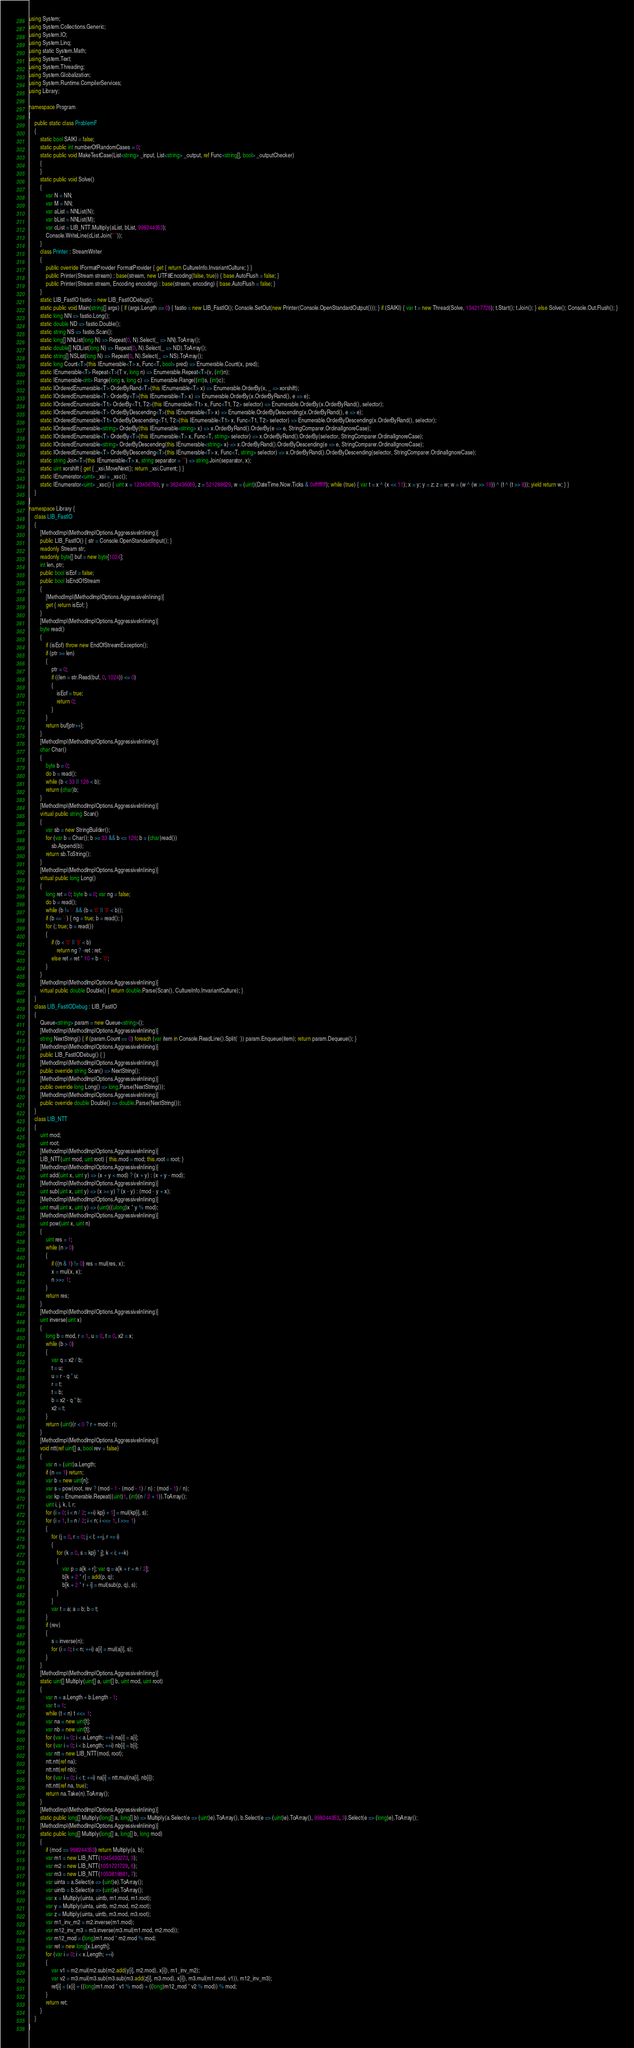<code> <loc_0><loc_0><loc_500><loc_500><_C#_>using System;
using System.Collections.Generic;
using System.IO;
using System.Linq;
using static System.Math;
using System.Text;
using System.Threading;
using System.Globalization;
using System.Runtime.CompilerServices;
using Library;

namespace Program
{
    public static class ProblemF
    {
        static bool SAIKI = false;
        static public int numberOfRandomCases = 0;
        static public void MakeTestCase(List<string> _input, List<string> _output, ref Func<string[], bool> _outputChecker)
        {
        }
        static public void Solve()
        {
            var N = NN;
            var M = NN;
            var aList = NNList(N);
            var bList = NNList(M);
            var cList = LIB_NTT.Multiply(aList, bList, 998244353);
            Console.WriteLine(cList.Join(" "));
        }
        class Printer : StreamWriter
        {
            public override IFormatProvider FormatProvider { get { return CultureInfo.InvariantCulture; } }
            public Printer(Stream stream) : base(stream, new UTF8Encoding(false, true)) { base.AutoFlush = false; }
            public Printer(Stream stream, Encoding encoding) : base(stream, encoding) { base.AutoFlush = false; }
        }
        static LIB_FastIO fastio = new LIB_FastIODebug();
        static public void Main(string[] args) { if (args.Length == 0) { fastio = new LIB_FastIO(); Console.SetOut(new Printer(Console.OpenStandardOutput())); } if (SAIKI) { var t = new Thread(Solve, 134217728); t.Start(); t.Join(); } else Solve(); Console.Out.Flush(); }
        static long NN => fastio.Long();
        static double ND => fastio.Double();
        static string NS => fastio.Scan();
        static long[] NNList(long N) => Repeat(0, N).Select(_ => NN).ToArray();
        static double[] NDList(long N) => Repeat(0, N).Select(_ => ND).ToArray();
        static string[] NSList(long N) => Repeat(0, N).Select(_ => NS).ToArray();
        static long Count<T>(this IEnumerable<T> x, Func<T, bool> pred) => Enumerable.Count(x, pred);
        static IEnumerable<T> Repeat<T>(T v, long n) => Enumerable.Repeat<T>(v, (int)n);
        static IEnumerable<int> Range(long s, long c) => Enumerable.Range((int)s, (int)c);
        static IOrderedEnumerable<T> OrderByRand<T>(this IEnumerable<T> x) => Enumerable.OrderBy(x, _ => xorshift);
        static IOrderedEnumerable<T> OrderBy<T>(this IEnumerable<T> x) => Enumerable.OrderBy(x.OrderByRand(), e => e);
        static IOrderedEnumerable<T1> OrderBy<T1, T2>(this IEnumerable<T1> x, Func<T1, T2> selector) => Enumerable.OrderBy(x.OrderByRand(), selector);
        static IOrderedEnumerable<T> OrderByDescending<T>(this IEnumerable<T> x) => Enumerable.OrderByDescending(x.OrderByRand(), e => e);
        static IOrderedEnumerable<T1> OrderByDescending<T1, T2>(this IEnumerable<T1> x, Func<T1, T2> selector) => Enumerable.OrderByDescending(x.OrderByRand(), selector);
        static IOrderedEnumerable<string> OrderBy(this IEnumerable<string> x) => x.OrderByRand().OrderBy(e => e, StringComparer.OrdinalIgnoreCase);
        static IOrderedEnumerable<T> OrderBy<T>(this IEnumerable<T> x, Func<T, string> selector) => x.OrderByRand().OrderBy(selector, StringComparer.OrdinalIgnoreCase);
        static IOrderedEnumerable<string> OrderByDescending(this IEnumerable<string> x) => x.OrderByRand().OrderByDescending(e => e, StringComparer.OrdinalIgnoreCase);
        static IOrderedEnumerable<T> OrderByDescending<T>(this IEnumerable<T> x, Func<T, string> selector) => x.OrderByRand().OrderByDescending(selector, StringComparer.OrdinalIgnoreCase);
        static string Join<T>(this IEnumerable<T> x, string separator = "") => string.Join(separator, x);
        static uint xorshift { get { _xsi.MoveNext(); return _xsi.Current; } }
        static IEnumerator<uint> _xsi = _xsc();
        static IEnumerator<uint> _xsc() { uint x = 123456789, y = 362436069, z = 521288629, w = (uint)(DateTime.Now.Ticks & 0xffffffff); while (true) { var t = x ^ (x << 11); x = y; y = z; z = w; w = (w ^ (w >> 19)) ^ (t ^ (t >> 8)); yield return w; } }
    }
}
namespace Library {
    class LIB_FastIO
    {
        [MethodImpl(MethodImplOptions.AggressiveInlining)]
        public LIB_FastIO() { str = Console.OpenStandardInput(); }
        readonly Stream str;
        readonly byte[] buf = new byte[1024];
        int len, ptr;
        public bool isEof = false;
        public bool IsEndOfStream
        {
            [MethodImpl(MethodImplOptions.AggressiveInlining)]
            get { return isEof; }
        }
        [MethodImpl(MethodImplOptions.AggressiveInlining)]
        byte read()
        {
            if (isEof) throw new EndOfStreamException();
            if (ptr >= len)
            {
                ptr = 0;
                if ((len = str.Read(buf, 0, 1024)) <= 0)
                {
                    isEof = true;
                    return 0;
                }
            }
            return buf[ptr++];
        }
        [MethodImpl(MethodImplOptions.AggressiveInlining)]
        char Char()
        {
            byte b = 0;
            do b = read();
            while (b < 33 || 126 < b);
            return (char)b;
        }
        [MethodImpl(MethodImplOptions.AggressiveInlining)]
        virtual public string Scan()
        {
            var sb = new StringBuilder();
            for (var b = Char(); b >= 33 && b <= 126; b = (char)read())
                sb.Append(b);
            return sb.ToString();
        }
        [MethodImpl(MethodImplOptions.AggressiveInlining)]
        virtual public long Long()
        {
            long ret = 0; byte b = 0; var ng = false;
            do b = read();
            while (b != '-' && (b < '0' || '9' < b));
            if (b == '-') { ng = true; b = read(); }
            for (; true; b = read())
            {
                if (b < '0' || '9' < b)
                    return ng ? -ret : ret;
                else ret = ret * 10 + b - '0';
            }
        }
        [MethodImpl(MethodImplOptions.AggressiveInlining)]
        virtual public double Double() { return double.Parse(Scan(), CultureInfo.InvariantCulture); }
    }
    class LIB_FastIODebug : LIB_FastIO
    {
        Queue<string> param = new Queue<string>();
        [MethodImpl(MethodImplOptions.AggressiveInlining)]
        string NextString() { if (param.Count == 0) foreach (var item in Console.ReadLine().Split(' ')) param.Enqueue(item); return param.Dequeue(); }
        [MethodImpl(MethodImplOptions.AggressiveInlining)]
        public LIB_FastIODebug() { }
        [MethodImpl(MethodImplOptions.AggressiveInlining)]
        public override string Scan() => NextString();
        [MethodImpl(MethodImplOptions.AggressiveInlining)]
        public override long Long() => long.Parse(NextString());
        [MethodImpl(MethodImplOptions.AggressiveInlining)]
        public override double Double() => double.Parse(NextString());
    }
    class LIB_NTT
    {
        uint mod;
        uint root;
        [MethodImpl(MethodImplOptions.AggressiveInlining)]
        LIB_NTT(uint mod, uint root) { this.mod = mod; this.root = root; }
        [MethodImpl(MethodImplOptions.AggressiveInlining)]
        uint add(uint x, uint y) => (x + y < mod) ? (x + y) : (x + y - mod);
        [MethodImpl(MethodImplOptions.AggressiveInlining)]
        uint sub(uint x, uint y) => (x >= y) ? (x - y) : (mod - y + x);
        [MethodImpl(MethodImplOptions.AggressiveInlining)]
        uint mul(uint x, uint y) => (uint)((ulong)x * y % mod);
        [MethodImpl(MethodImplOptions.AggressiveInlining)]
        uint pow(uint x, uint n)
        {
            uint res = 1;
            while (n > 0)
            {
                if ((n & 1) != 0) res = mul(res, x);
                x = mul(x, x);
                n >>= 1;
            }
            return res;
        }
        [MethodImpl(MethodImplOptions.AggressiveInlining)]
        uint inverse(uint x)
        {
            long b = mod, r = 1, u = 0, t = 0, x2 = x;
            while (b > 0)
            {
                var q = x2 / b;
                t = u;
                u = r - q * u;
                r = t;
                t = b;
                b = x2 - q * b;
                x2 = t;
            }
            return (uint)(r < 0 ? r + mod : r);
        }
        [MethodImpl(MethodImplOptions.AggressiveInlining)]
        void ntt(ref uint[] a, bool rev = false)
        {
            var n = (uint)a.Length;
            if (n == 1) return;
            var b = new uint[n];
            var s = pow(root, rev ? (mod - 1 - (mod - 1) / n) : (mod - 1) / n);
            var kp = Enumerable.Repeat((uint)1, (int)(n / 2 + 1)).ToArray();
            uint i, j, k, l, r;
            for (i = 0; i < n / 2; ++i) kp[i + 1] = mul(kp[i], s);
            for (i = 1, l = n / 2; i < n; i <<= 1, l >>= 1)
            {
                for (j = 0, r = 0; j < l; ++j, r += i)
                {
                    for (k = 0, s = kp[i * j]; k < i; ++k)
                    {
                        var p = a[k + r]; var q = a[k + r + n / 2];
                        b[k + 2 * r] = add(p, q);
                        b[k + 2 * r + i] = mul(sub(p, q), s);
                    }
                }
                var t = a; a = b; b = t;
            }
            if (rev)
            {
                s = inverse(n);
                for (i = 0; i < n; ++i) a[i] = mul(a[i], s);
            }
        }
        [MethodImpl(MethodImplOptions.AggressiveInlining)]
        static uint[] Multiply(uint[] a, uint[] b, uint mod, uint root)
        {
            var n = a.Length + b.Length - 1;
            var t = 1;
            while (t < n) t <<= 1;
            var na = new uint[t];
            var nb = new uint[t];
            for (var i = 0; i < a.Length; ++i) na[i] = a[i];
            for (var i = 0; i < b.Length; ++i) nb[i] = b[i];
            var ntt = new LIB_NTT(mod, root);
            ntt.ntt(ref na);
            ntt.ntt(ref nb);
            for (var i = 0; i < t; ++i) na[i] = ntt.mul(na[i], nb[i]);
            ntt.ntt(ref na, true);
            return na.Take(n).ToArray();
        }
        [MethodImpl(MethodImplOptions.AggressiveInlining)]
        static public long[] Multiply(long[] a, long[] b) => Multiply(a.Select(e => (uint)e).ToArray(), b.Select(e => (uint)e).ToArray(), 998244353, 3).Select(e => (long)e).ToArray();
        [MethodImpl(MethodImplOptions.AggressiveInlining)]
        static public long[] Multiply(long[] a, long[] b, long mod)
        {
            if (mod == 998244353) return Multiply(a, b);
            var m1 = new LIB_NTT(1045430273, 3);
            var m2 = new LIB_NTT(1051721729, 6);
            var m3 = new LIB_NTT(1053818881, 7);
            var uinta = a.Select(e => (uint)e).ToArray();
            var uintb = b.Select(e => (uint)e).ToArray();
            var x = Multiply(uinta, uintb, m1.mod, m1.root);
            var y = Multiply(uinta, uintb, m2.mod, m2.root);
            var z = Multiply(uinta, uintb, m3.mod, m3.root);
            var m1_inv_m2 = m2.inverse(m1.mod);
            var m12_inv_m3 = m3.inverse(m3.mul(m1.mod, m2.mod));
            var m12_mod = (long)m1.mod * m2.mod % mod;
            var ret = new long[x.Length];
            for (var i = 0; i < x.Length; ++i)
            {
                var v1 = m2.mul(m2.sub(m2.add(y[i], m2.mod), x[i]), m1_inv_m2);
                var v2 = m3.mul(m3.sub(m3.sub(m3.add(z[i], m3.mod), x[i]), m3.mul(m1.mod, v1)), m12_inv_m3);
                ret[i] = (x[i] + ((long)m1.mod * v1 % mod) + ((long)m12_mod * v2 % mod)) % mod;
            }
            return ret;
        }
    }
}
</code> 